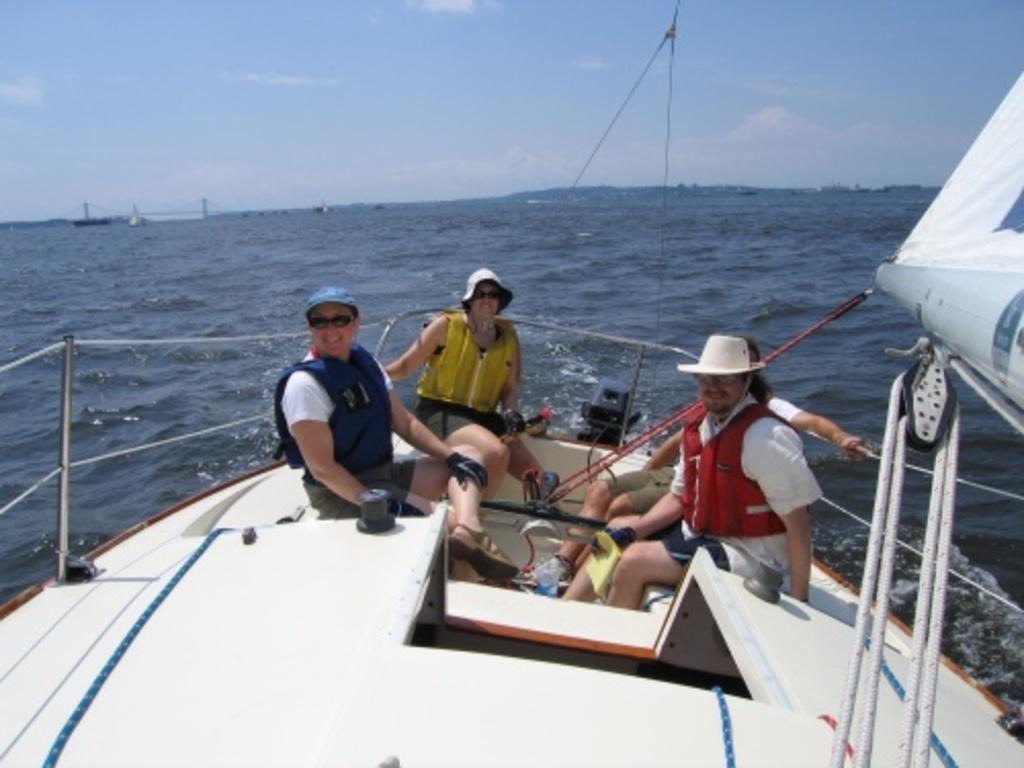Please provide a concise description of this image. In this picture there is a ship in the center of the image, on the water and there are people in it and there is water in the center of the image. 